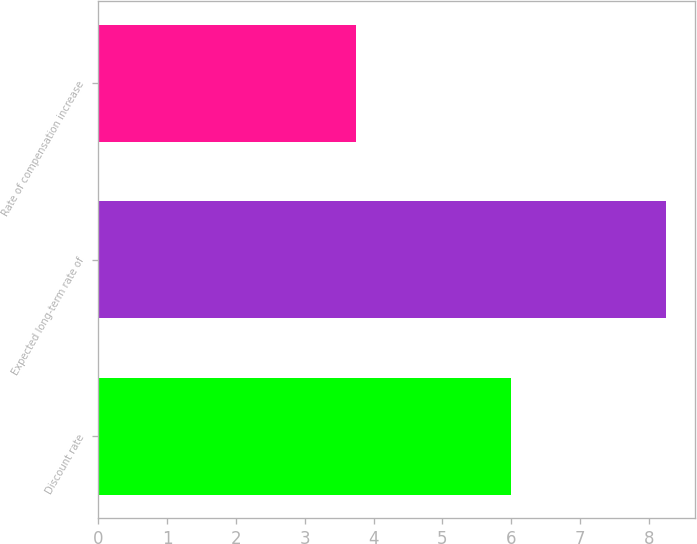Convert chart. <chart><loc_0><loc_0><loc_500><loc_500><bar_chart><fcel>Discount rate<fcel>Expected long-term rate of<fcel>Rate of compensation increase<nl><fcel>6<fcel>8.25<fcel>3.75<nl></chart> 